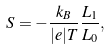Convert formula to latex. <formula><loc_0><loc_0><loc_500><loc_500>S = - \frac { k _ { B } } { | e | T } \frac { L _ { 1 } } { L _ { 0 } } ,</formula> 